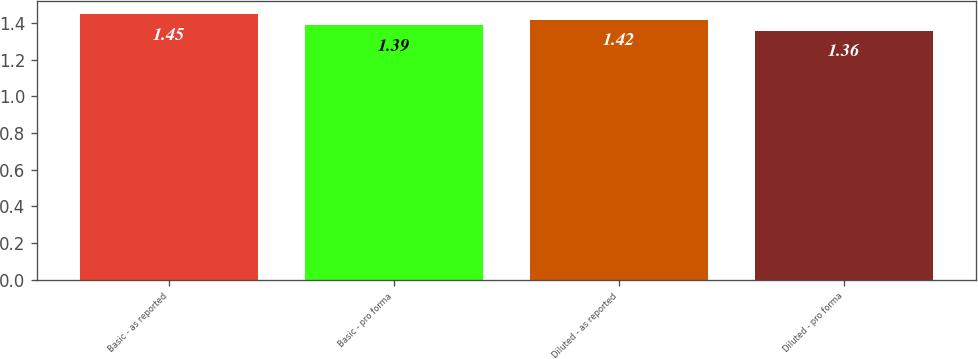Convert chart. <chart><loc_0><loc_0><loc_500><loc_500><bar_chart><fcel>Basic - as reported<fcel>Basic - pro forma<fcel>Diluted - as reported<fcel>Diluted - pro forma<nl><fcel>1.45<fcel>1.39<fcel>1.42<fcel>1.36<nl></chart> 